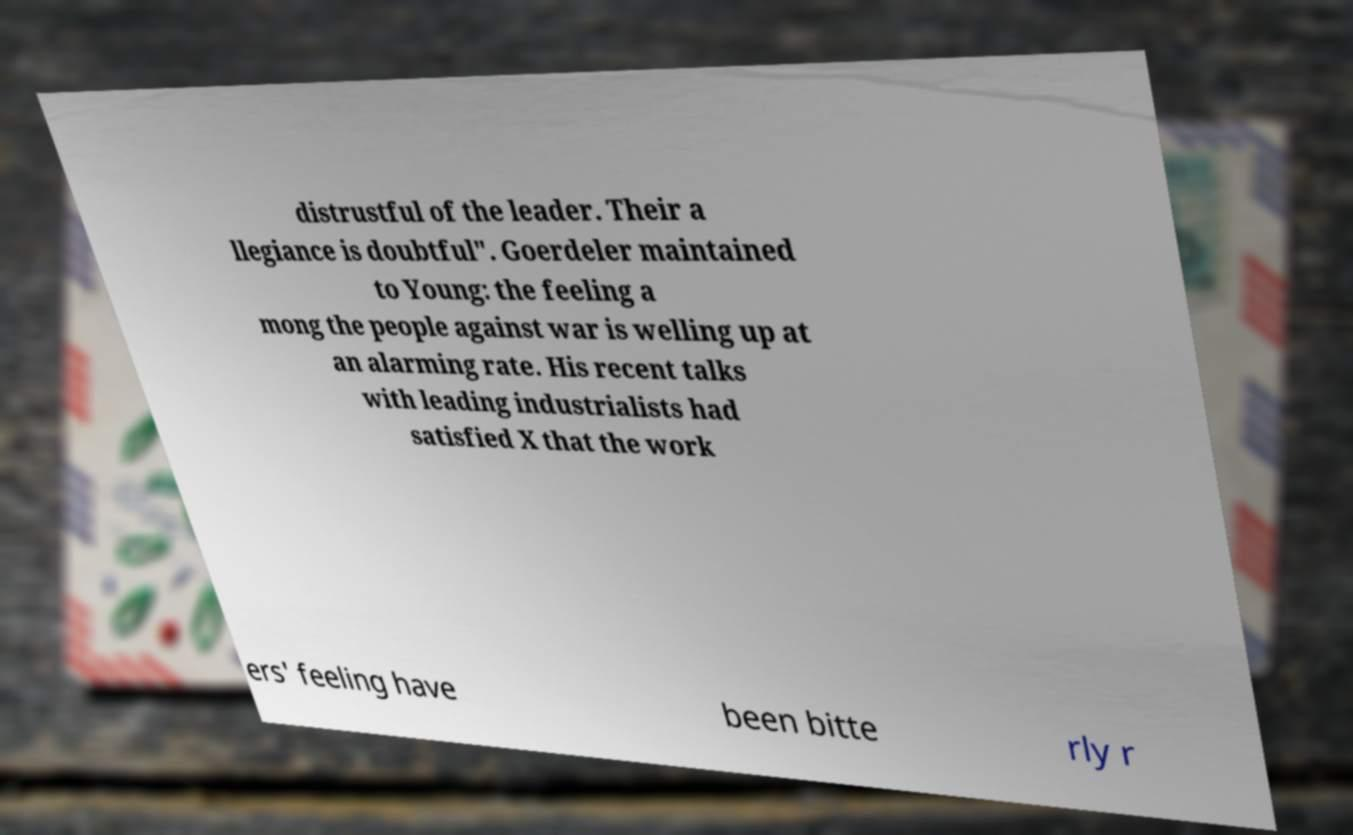There's text embedded in this image that I need extracted. Can you transcribe it verbatim? distrustful of the leader. Their a llegiance is doubtful". Goerdeler maintained to Young: the feeling a mong the people against war is welling up at an alarming rate. His recent talks with leading industrialists had satisfied X that the work ers' feeling have been bitte rly r 